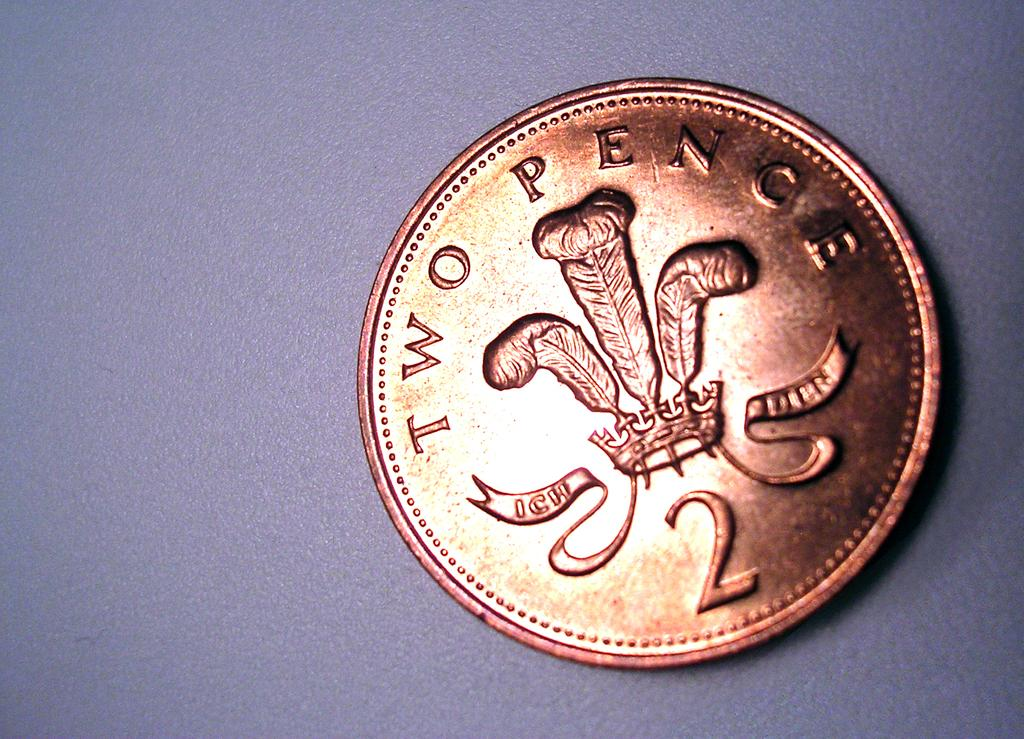Provide a one-sentence caption for the provided image. A two pence coin is on a blue colored background. 